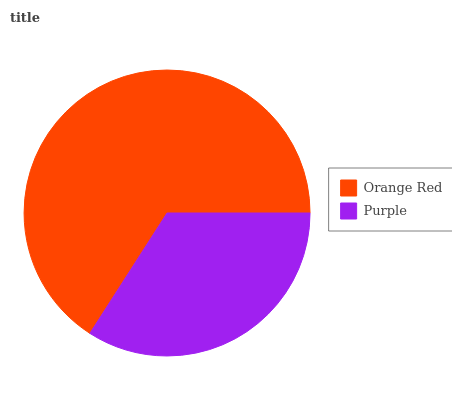Is Purple the minimum?
Answer yes or no. Yes. Is Orange Red the maximum?
Answer yes or no. Yes. Is Purple the maximum?
Answer yes or no. No. Is Orange Red greater than Purple?
Answer yes or no. Yes. Is Purple less than Orange Red?
Answer yes or no. Yes. Is Purple greater than Orange Red?
Answer yes or no. No. Is Orange Red less than Purple?
Answer yes or no. No. Is Orange Red the high median?
Answer yes or no. Yes. Is Purple the low median?
Answer yes or no. Yes. Is Purple the high median?
Answer yes or no. No. Is Orange Red the low median?
Answer yes or no. No. 